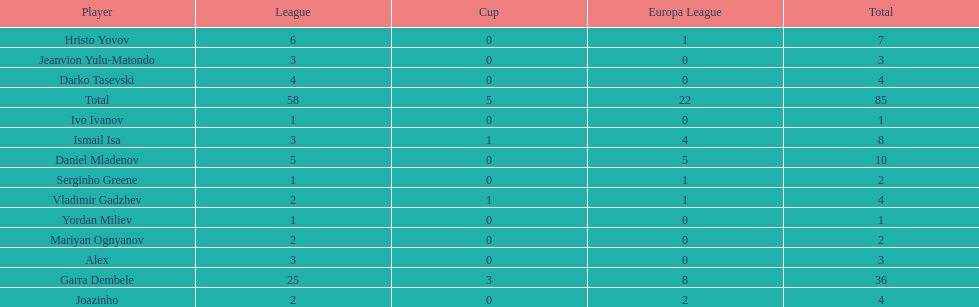How many participants achieved a total score of 4? 3. I'm looking to parse the entire table for insights. Could you assist me with that? {'header': ['Player', 'League', 'Cup', 'Europa League', 'Total'], 'rows': [['Hristo Yovov', '6', '0', '1', '7'], ['Jeanvion Yulu-Matondo', '3', '0', '0', '3'], ['Darko Tasevski', '4', '0', '0', '4'], ['Total', '58', '5', '22', '85'], ['Ivo Ivanov', '1', '0', '0', '1'], ['Ismail Isa', '3', '1', '4', '8'], ['Daniel Mladenov', '5', '0', '5', '10'], ['Serginho Greene', '1', '0', '1', '2'], ['Vladimir Gadzhev', '2', '1', '1', '4'], ['Yordan Miliev', '1', '0', '0', '1'], ['Mariyan Ognyanov', '2', '0', '0', '2'], ['Alex', '3', '0', '0', '3'], ['Garra Dembele', '25', '3', '8', '36'], ['Joazinho', '2', '0', '2', '4']]} 